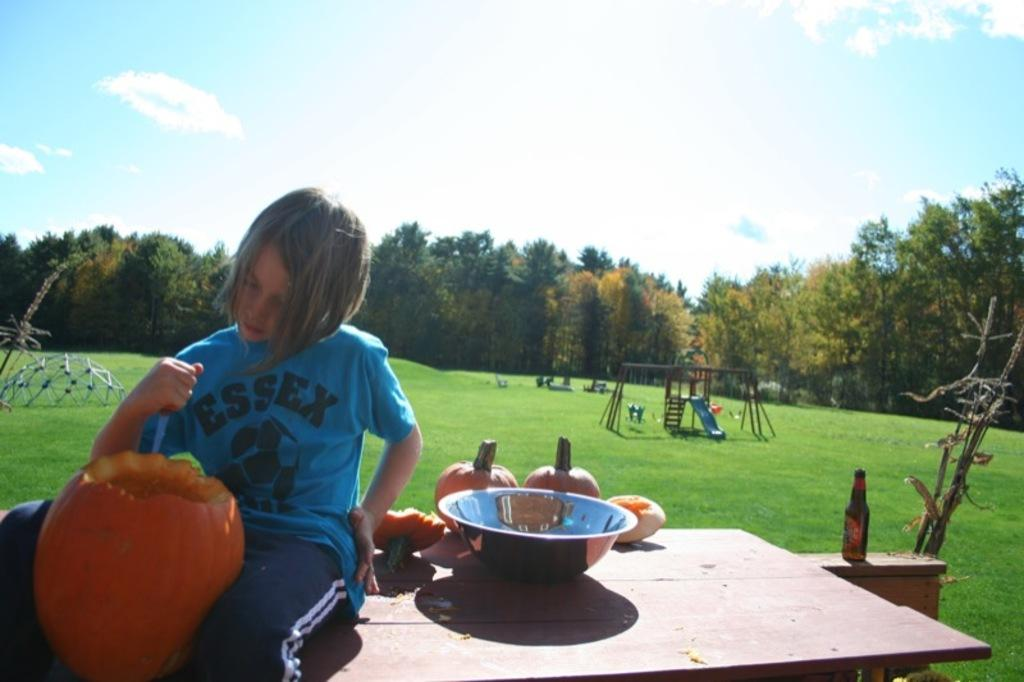What is the girl doing in the image? The girl is seated on the table in the image. What object is in front of the girl? There is a pumpkin in front of the girl. What can be seen besides the girl and the pumpkin? There is a bottle visible in the image, as well as trees and metal rods. What is the smell of the pumpkin in the image? The image does not provide information about the smell of the pumpkin, so it cannot be determined. 